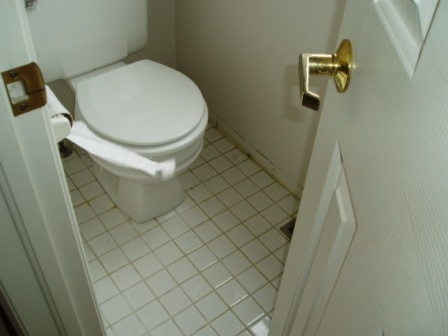Describe the objects in this image and their specific colors. I can see a toilet in darkgray, gray, and lightgray tones in this image. 